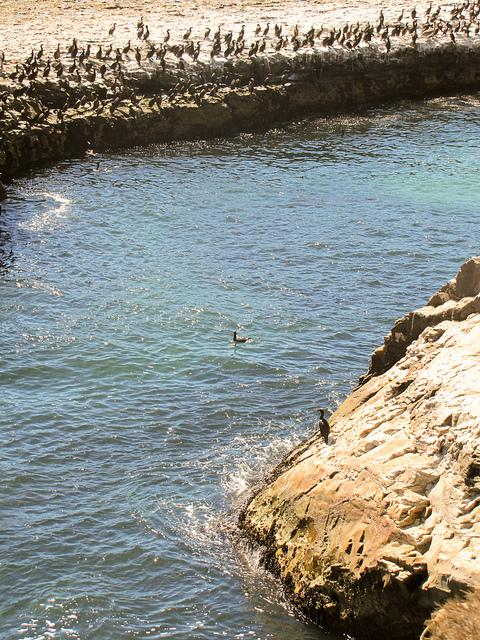What surface are all the birds standing on next to the big river?

Choices:
A) stone
B) dirt
C) wood
D) grass stone 